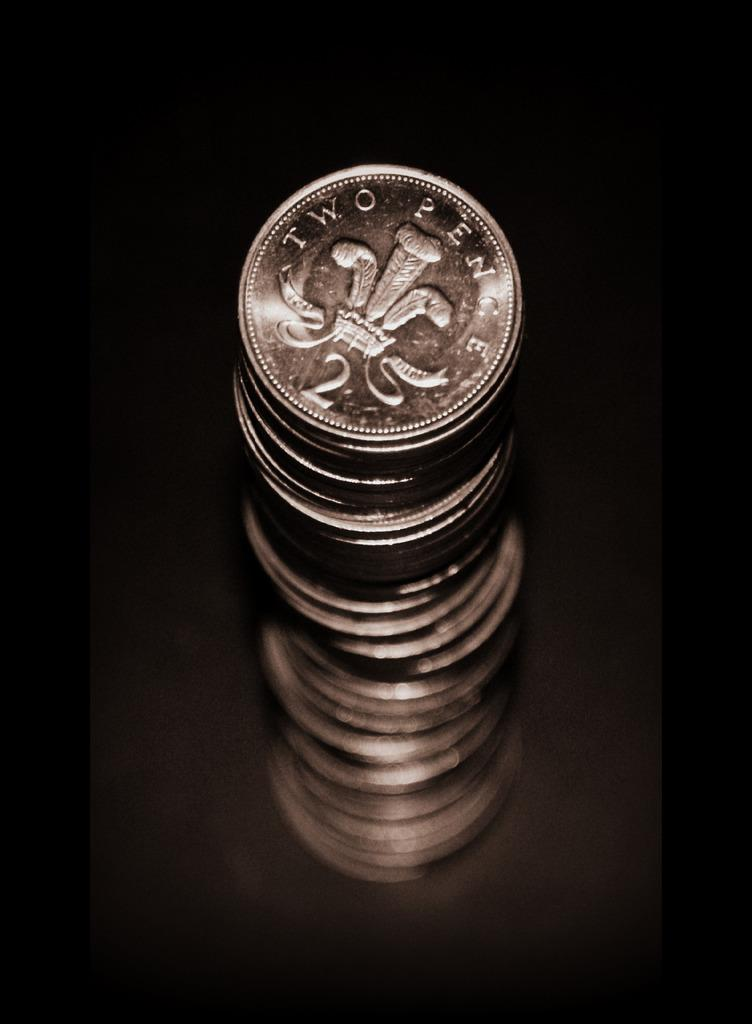Provide a one-sentence caption for the provided image. A tall stack of Two Pence silver coins against a black background. 